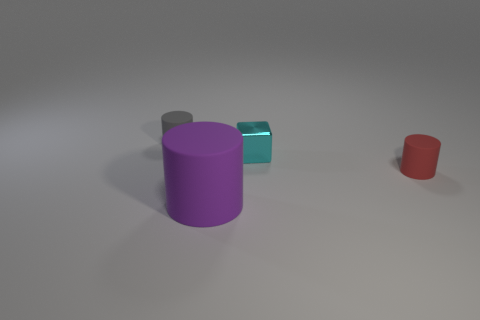What number of other objects are the same size as the purple thing?
Your answer should be very brief. 0. There is a gray cylinder; are there any red cylinders on the left side of it?
Your answer should be compact. No. What is the color of the rubber thing that is on the left side of the tiny red thing and in front of the small cyan block?
Offer a very short reply. Purple. There is a cylinder that is behind the tiny rubber cylinder that is to the right of the gray rubber cylinder; what size is it?
Offer a terse response. Small. What number of balls are purple matte things or tiny cyan rubber objects?
Offer a very short reply. 0. The metal cube that is the same size as the gray rubber cylinder is what color?
Your response must be concise. Cyan. There is a cyan thing behind the cylinder in front of the small red rubber cylinder; what shape is it?
Your answer should be very brief. Cube. Do the metallic thing that is on the right side of the gray rubber object and the gray rubber thing have the same size?
Ensure brevity in your answer.  Yes. How many other things are there of the same material as the tiny block?
Ensure brevity in your answer.  0. How many cyan objects are small things or large cylinders?
Your answer should be compact. 1. 